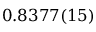<formula> <loc_0><loc_0><loc_500><loc_500>0 . 8 3 7 7 ( 1 5 )</formula> 